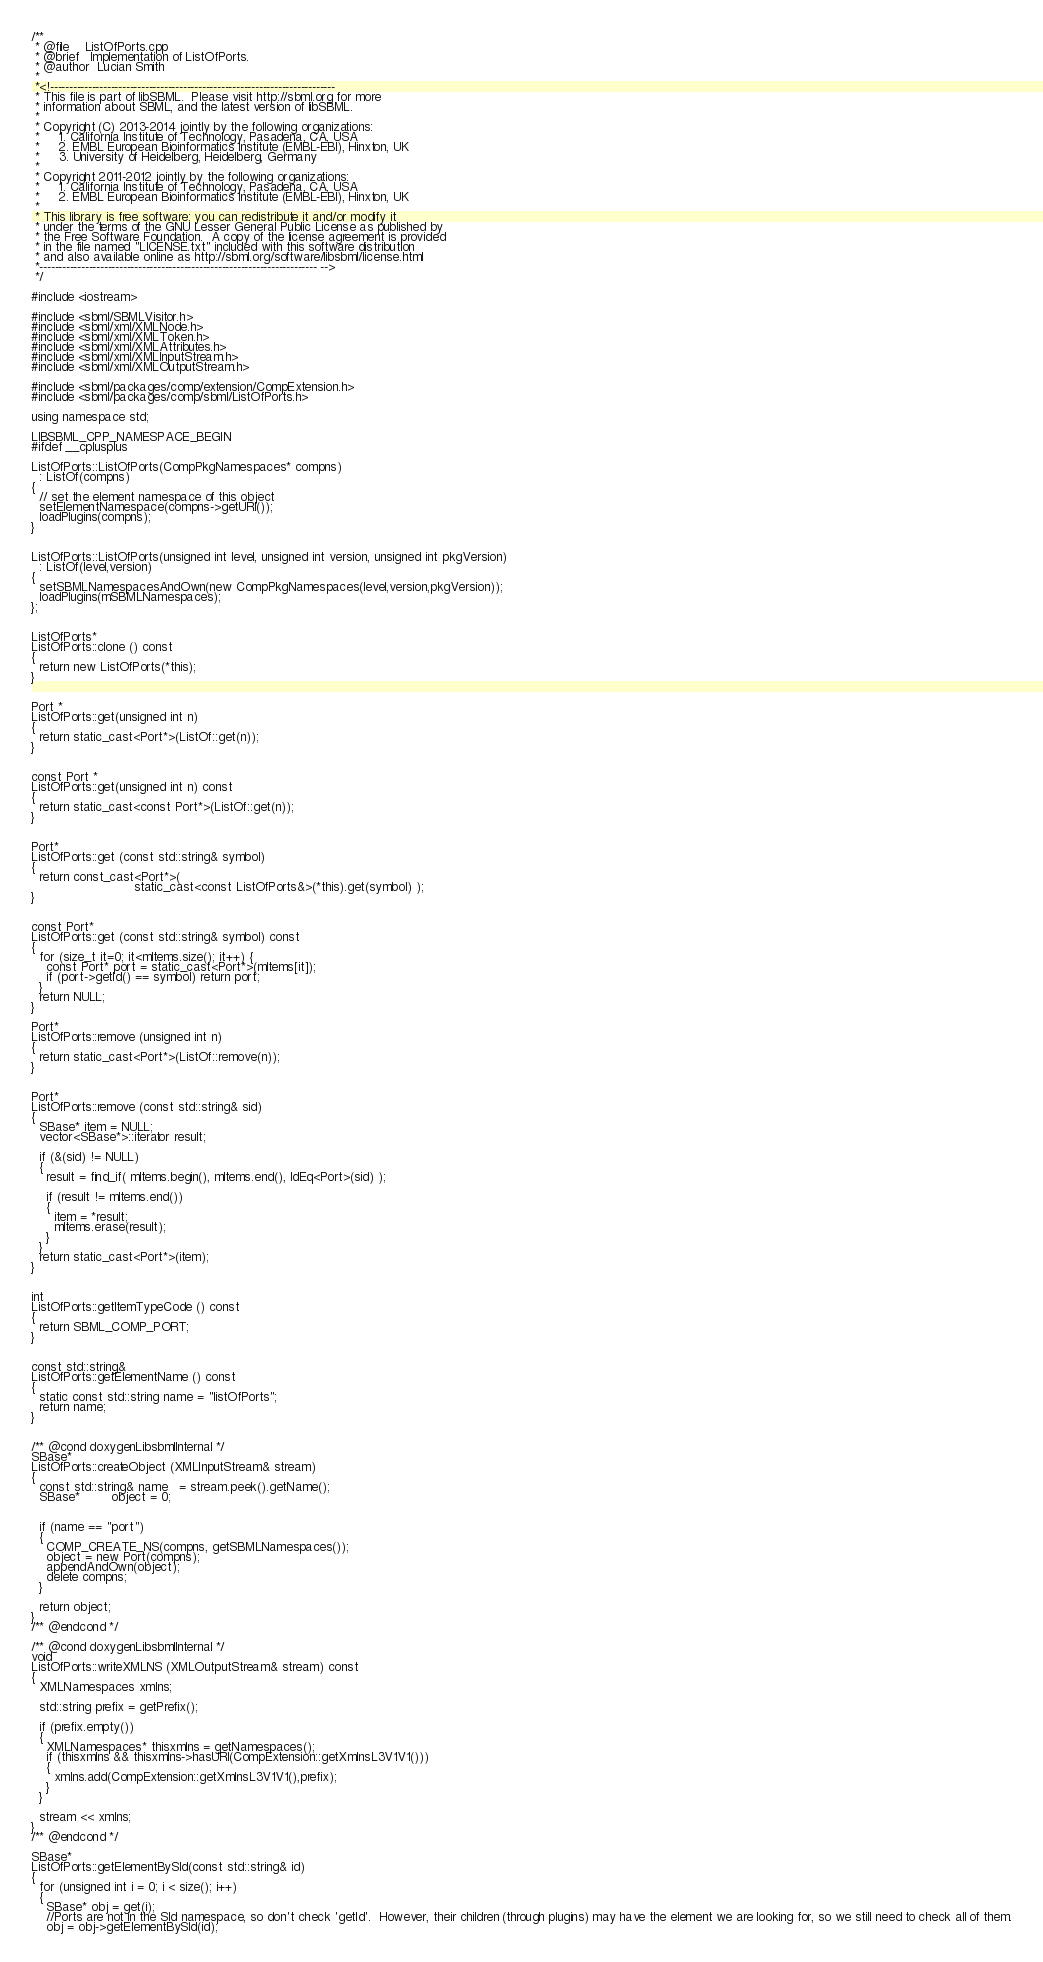<code> <loc_0><loc_0><loc_500><loc_500><_C++_>/**
 * @file    ListOfPorts.cpp
 * @brief   Implementation of ListOfPorts.
 * @author  Lucian Smith
 *
 *<!---------------------------------------------------------------------------
 * This file is part of libSBML.  Please visit http://sbml.org for more
 * information about SBML, and the latest version of libSBML.
 *
 * Copyright (C) 2013-2014 jointly by the following organizations:
 *     1. California Institute of Technology, Pasadena, CA, USA
 *     2. EMBL European Bioinformatics Institute (EMBL-EBI), Hinxton, UK
 *     3. University of Heidelberg, Heidelberg, Germany
 * 
 * Copyright 2011-2012 jointly by the following organizations:
 *     1. California Institute of Technology, Pasadena, CA, USA
 *     2. EMBL European Bioinformatics Institute (EMBL-EBI), Hinxton, UK
 *
 * This library is free software; you can redistribute it and/or modify it
 * under the terms of the GNU Lesser General Public License as published by
 * the Free Software Foundation.  A copy of the license agreement is provided
 * in the file named "LICENSE.txt" included with this software distribution
 * and also available online as http://sbml.org/software/libsbml/license.html
 *------------------------------------------------------------------------- -->
 */

#include <iostream>

#include <sbml/SBMLVisitor.h>
#include <sbml/xml/XMLNode.h>
#include <sbml/xml/XMLToken.h>
#include <sbml/xml/XMLAttributes.h>
#include <sbml/xml/XMLInputStream.h>
#include <sbml/xml/XMLOutputStream.h>

#include <sbml/packages/comp/extension/CompExtension.h>
#include <sbml/packages/comp/sbml/ListOfPorts.h>

using namespace std;

LIBSBML_CPP_NAMESPACE_BEGIN
#ifdef __cplusplus

ListOfPorts::ListOfPorts(CompPkgNamespaces* compns)
  : ListOf(compns)
{
  // set the element namespace of this object
  setElementNamespace(compns->getURI());
  loadPlugins(compns);
}


ListOfPorts::ListOfPorts(unsigned int level, unsigned int version, unsigned int pkgVersion)
  : ListOf(level,version)
{
  setSBMLNamespacesAndOwn(new CompPkgNamespaces(level,version,pkgVersion));
  loadPlugins(mSBMLNamespaces);
};


ListOfPorts*
ListOfPorts::clone () const
{
  return new ListOfPorts(*this);
}


Port *
ListOfPorts::get(unsigned int n)
{
  return static_cast<Port*>(ListOf::get(n));
}


const Port *
ListOfPorts::get(unsigned int n) const
{
  return static_cast<const Port*>(ListOf::get(n));
}


Port*
ListOfPorts::get (const std::string& symbol)
{
  return const_cast<Port*>( 
                           static_cast<const ListOfPorts&>(*this).get(symbol) );
}


const Port*
ListOfPorts::get (const std::string& symbol) const
{
  for (size_t it=0; it<mItems.size(); it++) {
    const Port* port = static_cast<Port*>(mItems[it]);
    if (port->getId() == symbol) return port;
  }
  return NULL;
}

Port*
ListOfPorts::remove (unsigned int n)
{
  return static_cast<Port*>(ListOf::remove(n));
}


Port*
ListOfPorts::remove (const std::string& sid)
{
  SBase* item = NULL;
  vector<SBase*>::iterator result;

  if (&(sid) != NULL)
  {
    result = find_if( mItems.begin(), mItems.end(), IdEq<Port>(sid) );

    if (result != mItems.end())
    {
      item = *result;
      mItems.erase(result);
    }
  }
  return static_cast<Port*>(item);
}


int
ListOfPorts::getItemTypeCode () const
{
  return SBML_COMP_PORT;
}


const std::string&
ListOfPorts::getElementName () const
{
  static const std::string name = "listOfPorts";
  return name;
}


/** @cond doxygenLibsbmlInternal */
SBase*
ListOfPorts::createObject (XMLInputStream& stream)
{
  const std::string& name   = stream.peek().getName();
  SBase*        object = 0;


  if (name == "port")
  {
    COMP_CREATE_NS(compns, getSBMLNamespaces());
    object = new Port(compns);
    appendAndOwn(object);
    delete compns;
  }

  return object;
}
/** @endcond */

/** @cond doxygenLibsbmlInternal */
void 
ListOfPorts::writeXMLNS (XMLOutputStream& stream) const
{
  XMLNamespaces xmlns;

  std::string prefix = getPrefix();

  if (prefix.empty())
  {
    XMLNamespaces* thisxmlns = getNamespaces();
    if (thisxmlns && thisxmlns->hasURI(CompExtension::getXmlnsL3V1V1()))
    {
      xmlns.add(CompExtension::getXmlnsL3V1V1(),prefix);
    }
  }

  stream << xmlns;
}
/** @endcond */

SBase*
ListOfPorts::getElementBySId(const std::string& id)
{
  for (unsigned int i = 0; i < size(); i++)
  {
    SBase* obj = get(i);
    //Ports are not in the SId namespace, so don't check 'getId'.  However, their children (through plugins) may have the element we are looking for, so we still need to check all of them.
    obj = obj->getElementBySId(id);</code> 